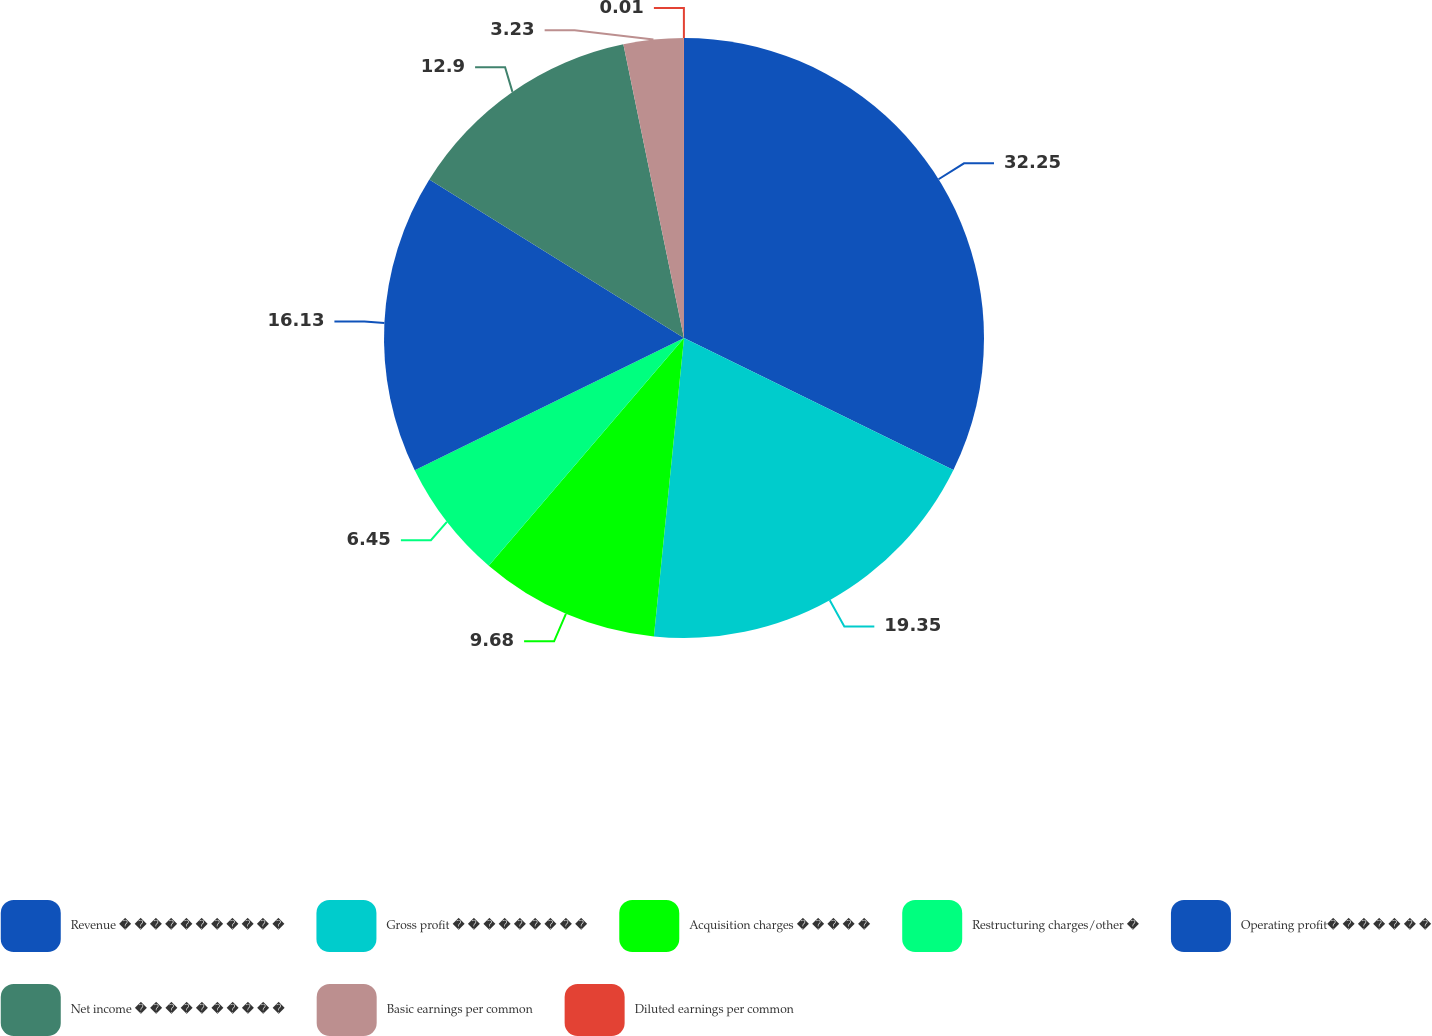Convert chart to OTSL. <chart><loc_0><loc_0><loc_500><loc_500><pie_chart><fcel>Revenue � � � � � � � � � � �<fcel>Gross profit � � � � � � � � �<fcel>Acquisition charges � � � � �<fcel>Restructuring charges/other �<fcel>Operating profit� � � � � � �<fcel>Net income � � � � � � � � � �<fcel>Basic earnings per common<fcel>Diluted earnings per common<nl><fcel>32.25%<fcel>19.35%<fcel>9.68%<fcel>6.45%<fcel>16.13%<fcel>12.9%<fcel>3.23%<fcel>0.01%<nl></chart> 